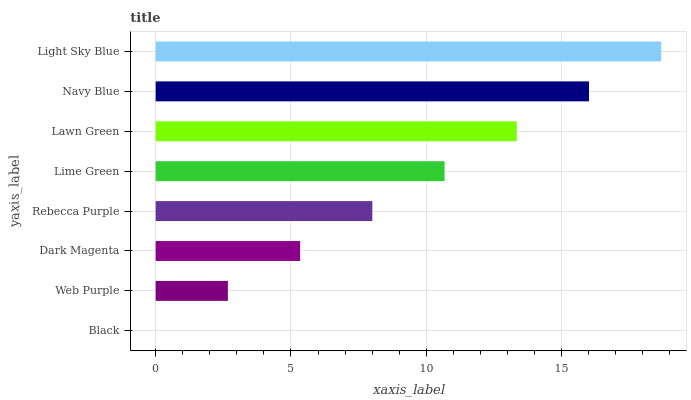Is Black the minimum?
Answer yes or no. Yes. Is Light Sky Blue the maximum?
Answer yes or no. Yes. Is Web Purple the minimum?
Answer yes or no. No. Is Web Purple the maximum?
Answer yes or no. No. Is Web Purple greater than Black?
Answer yes or no. Yes. Is Black less than Web Purple?
Answer yes or no. Yes. Is Black greater than Web Purple?
Answer yes or no. No. Is Web Purple less than Black?
Answer yes or no. No. Is Lime Green the high median?
Answer yes or no. Yes. Is Rebecca Purple the low median?
Answer yes or no. Yes. Is Web Purple the high median?
Answer yes or no. No. Is Navy Blue the low median?
Answer yes or no. No. 